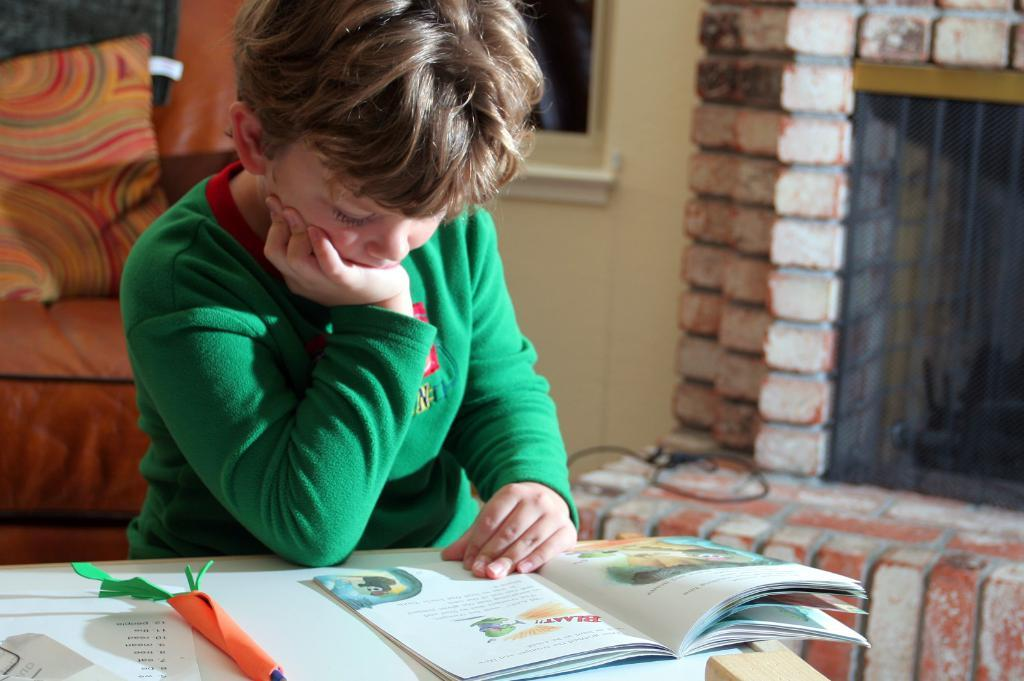Provide a one-sentence caption for the provided image. A boy reading a book that says "Blaat" on top in red. 